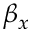<formula> <loc_0><loc_0><loc_500><loc_500>\beta _ { x }</formula> 